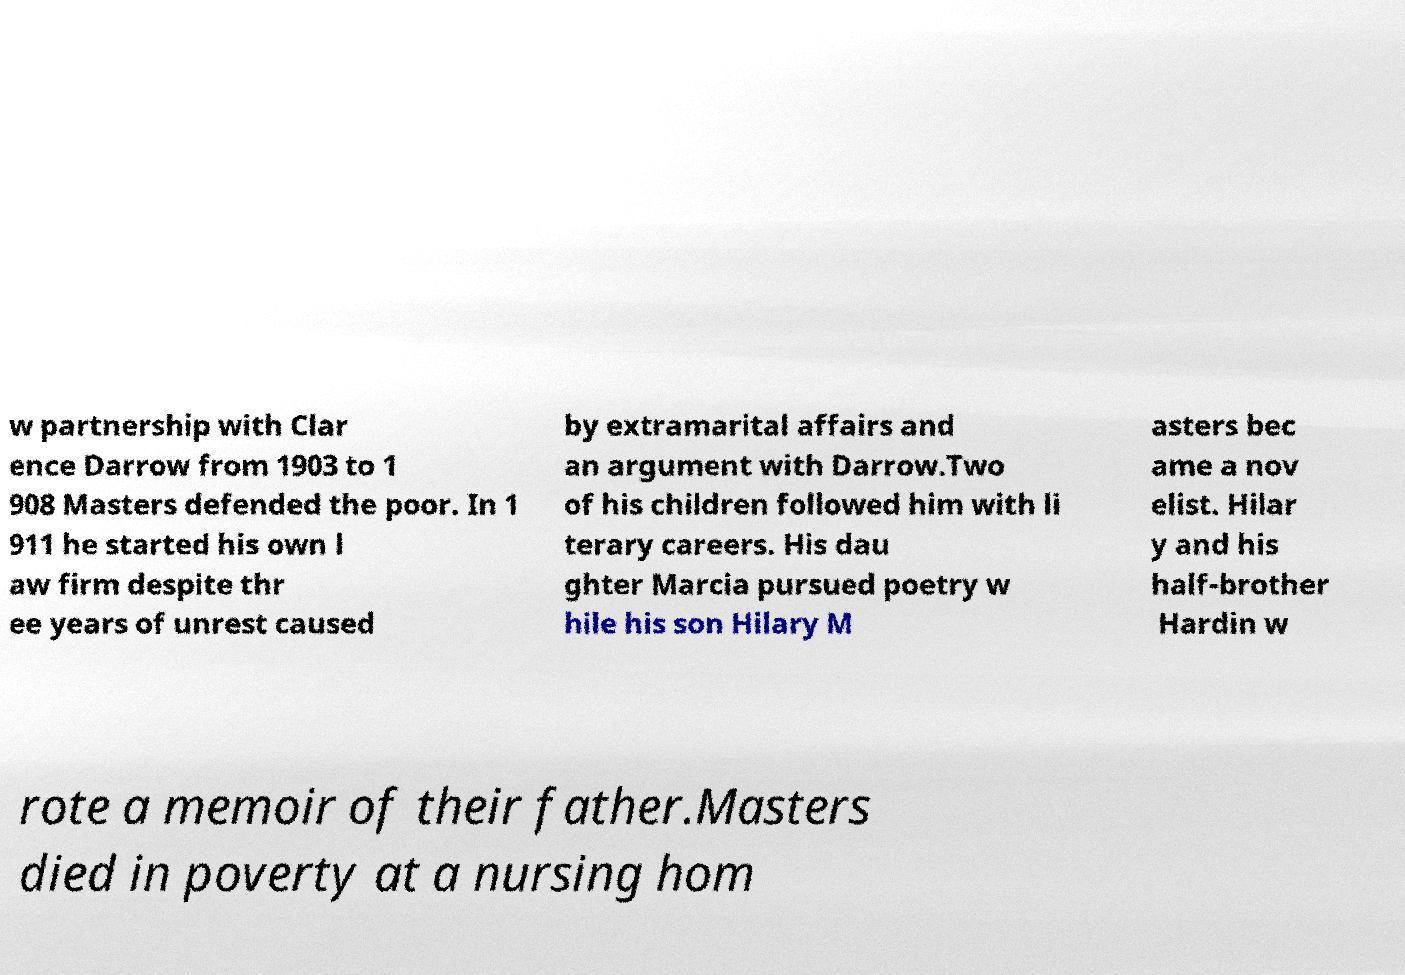I need the written content from this picture converted into text. Can you do that? w partnership with Clar ence Darrow from 1903 to 1 908 Masters defended the poor. In 1 911 he started his own l aw firm despite thr ee years of unrest caused by extramarital affairs and an argument with Darrow.Two of his children followed him with li terary careers. His dau ghter Marcia pursued poetry w hile his son Hilary M asters bec ame a nov elist. Hilar y and his half-brother Hardin w rote a memoir of their father.Masters died in poverty at a nursing hom 